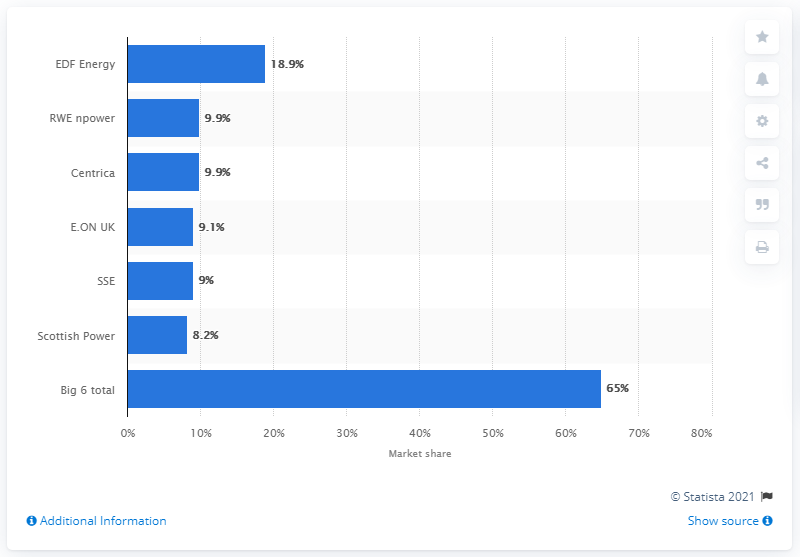Indicate a few pertinent items in this graphic. In 2010, E.ON UK's market share was 8.2%. 